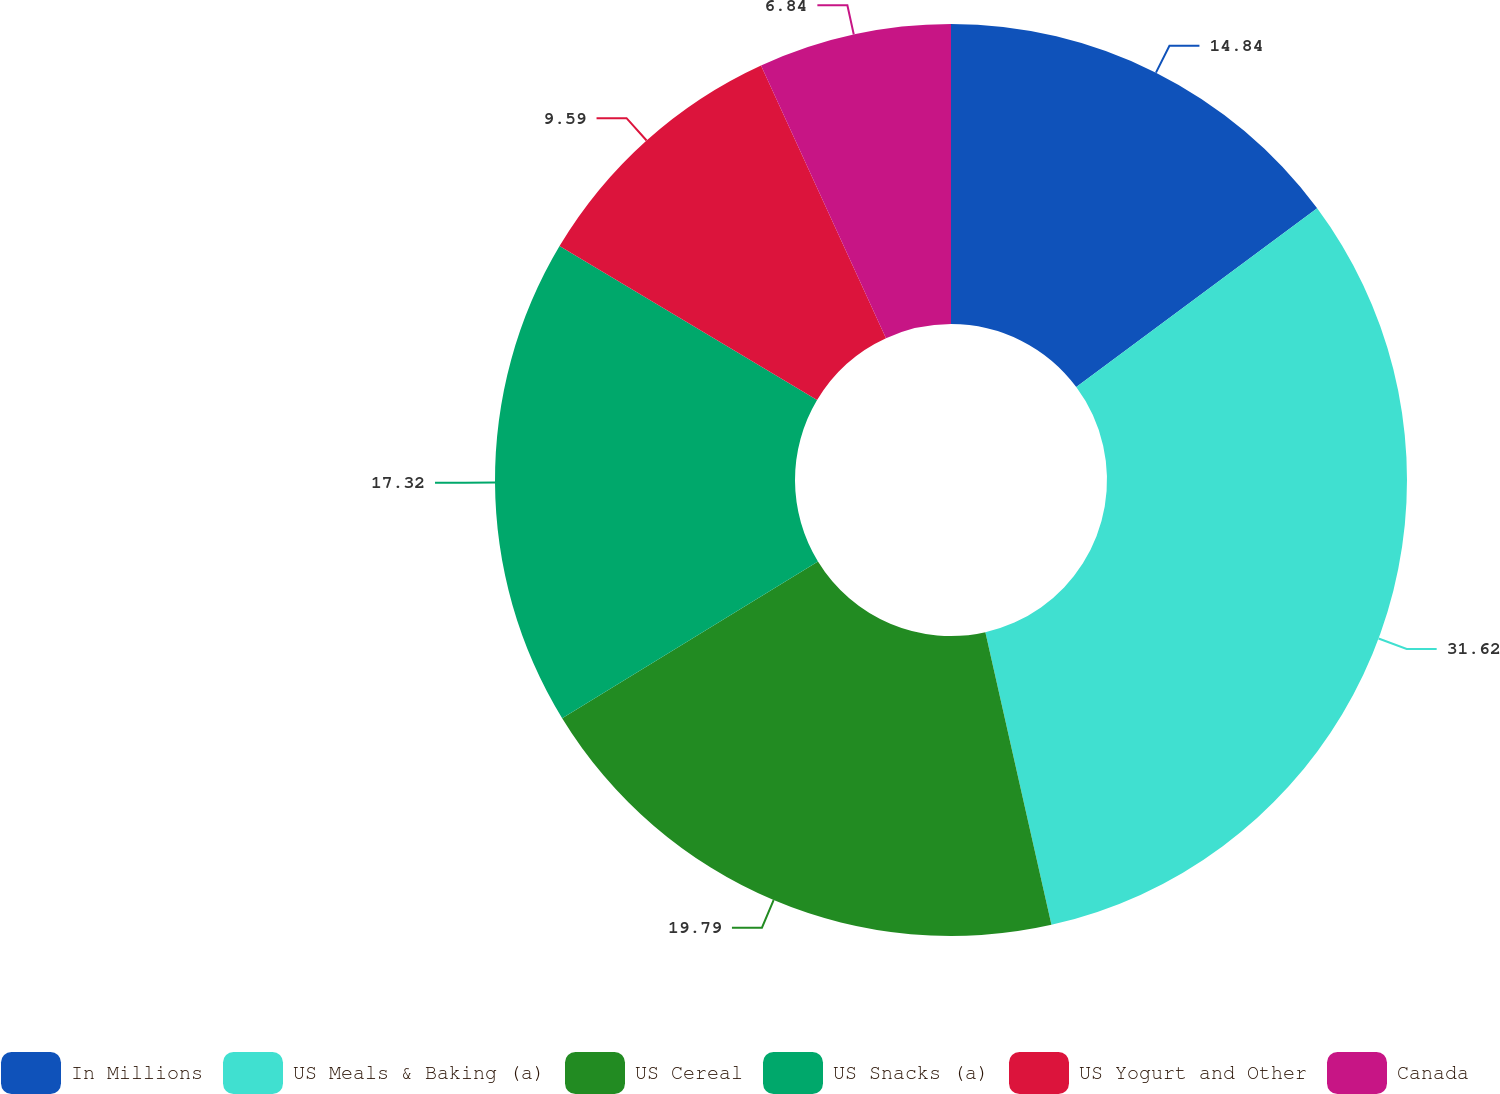<chart> <loc_0><loc_0><loc_500><loc_500><pie_chart><fcel>In Millions<fcel>US Meals & Baking (a)<fcel>US Cereal<fcel>US Snacks (a)<fcel>US Yogurt and Other<fcel>Canada<nl><fcel>14.84%<fcel>31.63%<fcel>19.79%<fcel>17.32%<fcel>9.59%<fcel>6.84%<nl></chart> 